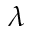<formula> <loc_0><loc_0><loc_500><loc_500>\lambda</formula> 